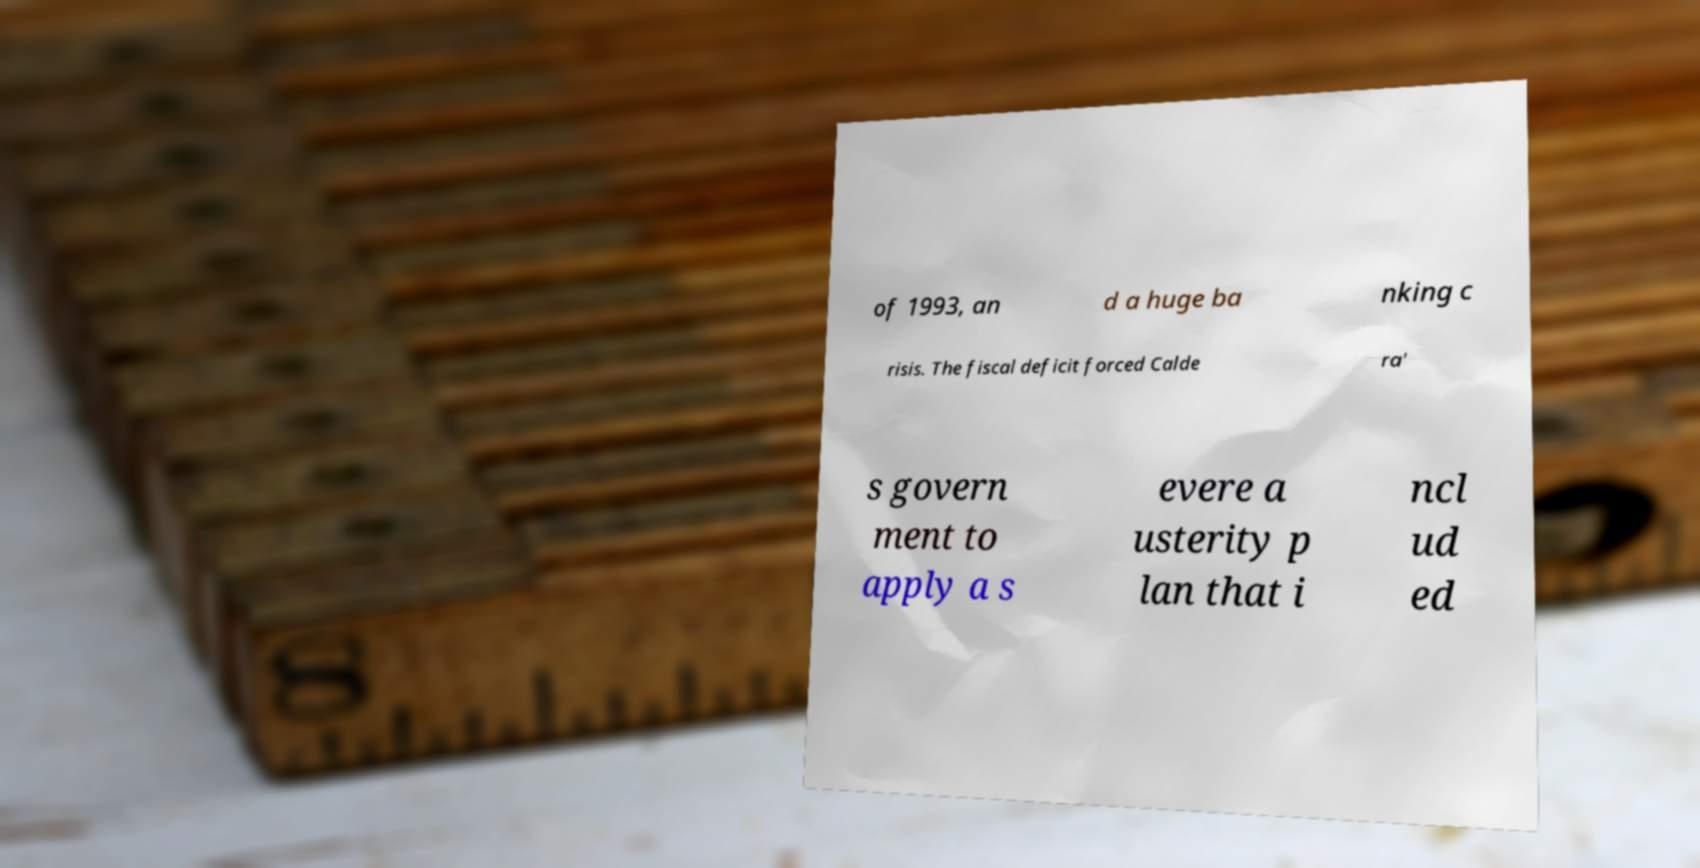Please identify and transcribe the text found in this image. of 1993, an d a huge ba nking c risis. The fiscal deficit forced Calde ra' s govern ment to apply a s evere a usterity p lan that i ncl ud ed 